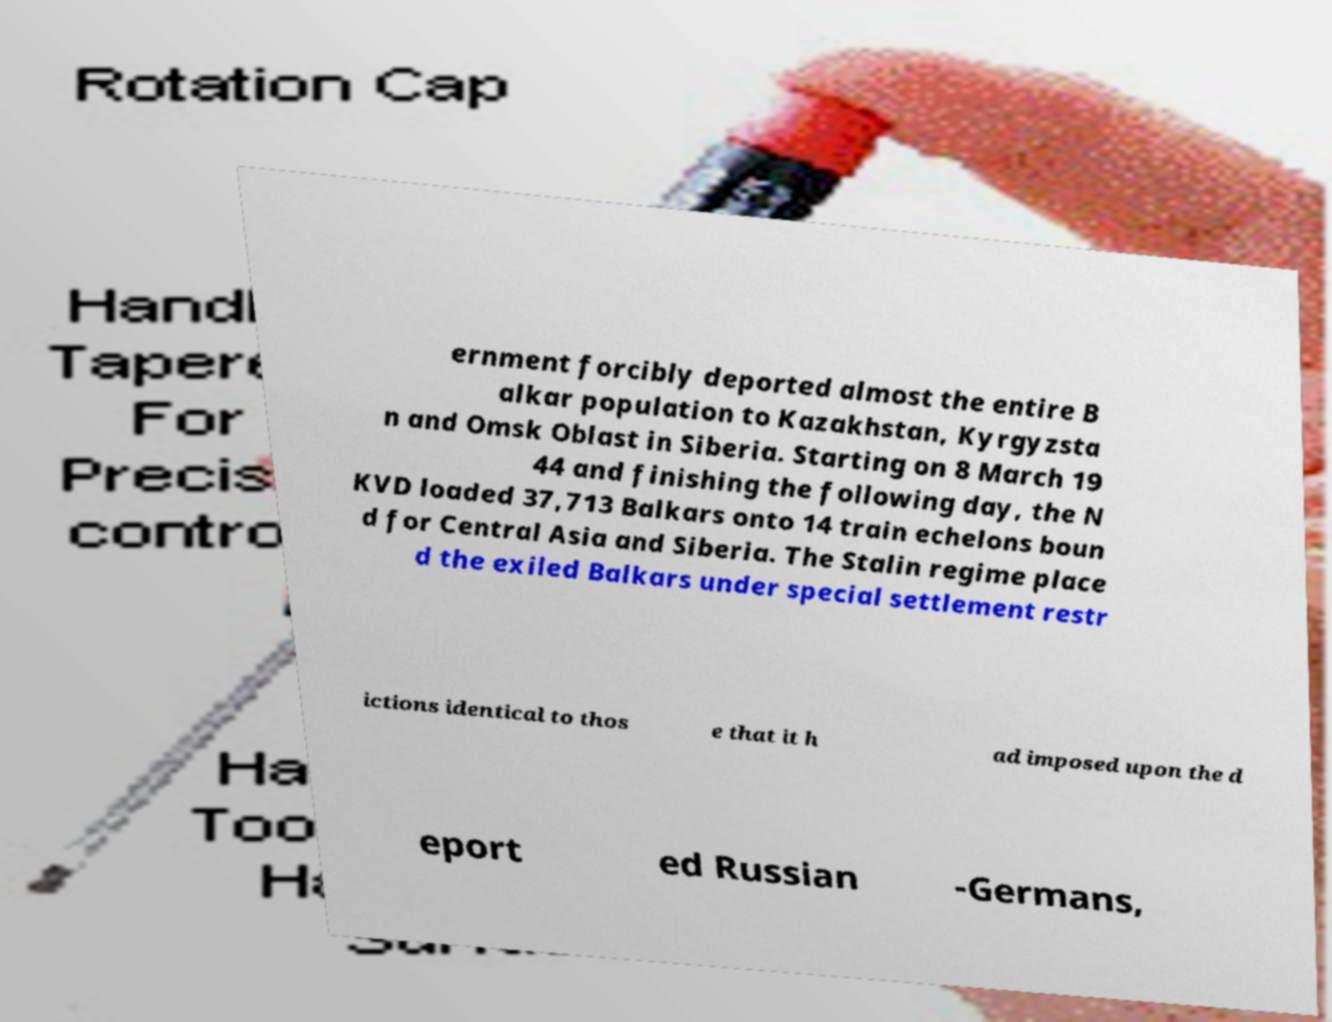What messages or text are displayed in this image? I need them in a readable, typed format. ernment forcibly deported almost the entire B alkar population to Kazakhstan, Kyrgyzsta n and Omsk Oblast in Siberia. Starting on 8 March 19 44 and finishing the following day, the N KVD loaded 37,713 Balkars onto 14 train echelons boun d for Central Asia and Siberia. The Stalin regime place d the exiled Balkars under special settlement restr ictions identical to thos e that it h ad imposed upon the d eport ed Russian -Germans, 